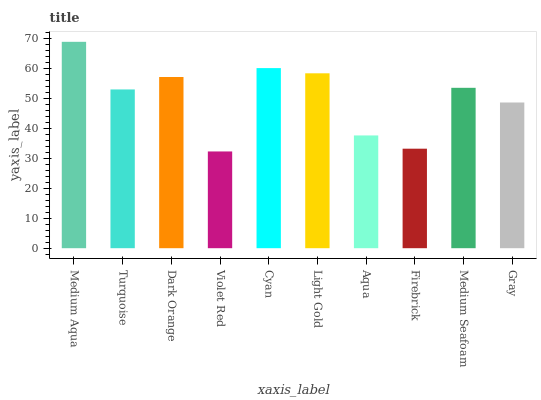Is Violet Red the minimum?
Answer yes or no. Yes. Is Medium Aqua the maximum?
Answer yes or no. Yes. Is Turquoise the minimum?
Answer yes or no. No. Is Turquoise the maximum?
Answer yes or no. No. Is Medium Aqua greater than Turquoise?
Answer yes or no. Yes. Is Turquoise less than Medium Aqua?
Answer yes or no. Yes. Is Turquoise greater than Medium Aqua?
Answer yes or no. No. Is Medium Aqua less than Turquoise?
Answer yes or no. No. Is Medium Seafoam the high median?
Answer yes or no. Yes. Is Turquoise the low median?
Answer yes or no. Yes. Is Cyan the high median?
Answer yes or no. No. Is Medium Aqua the low median?
Answer yes or no. No. 